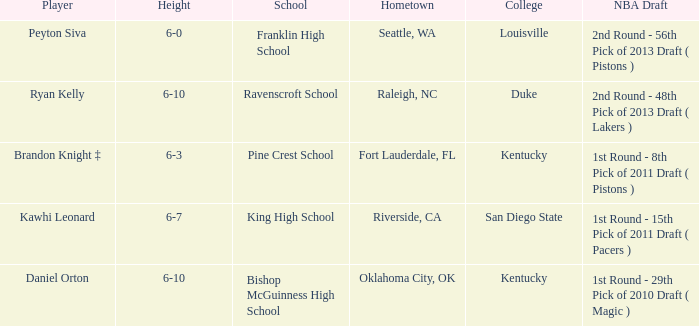Which school is in Raleigh, NC? Ravenscroft School. 